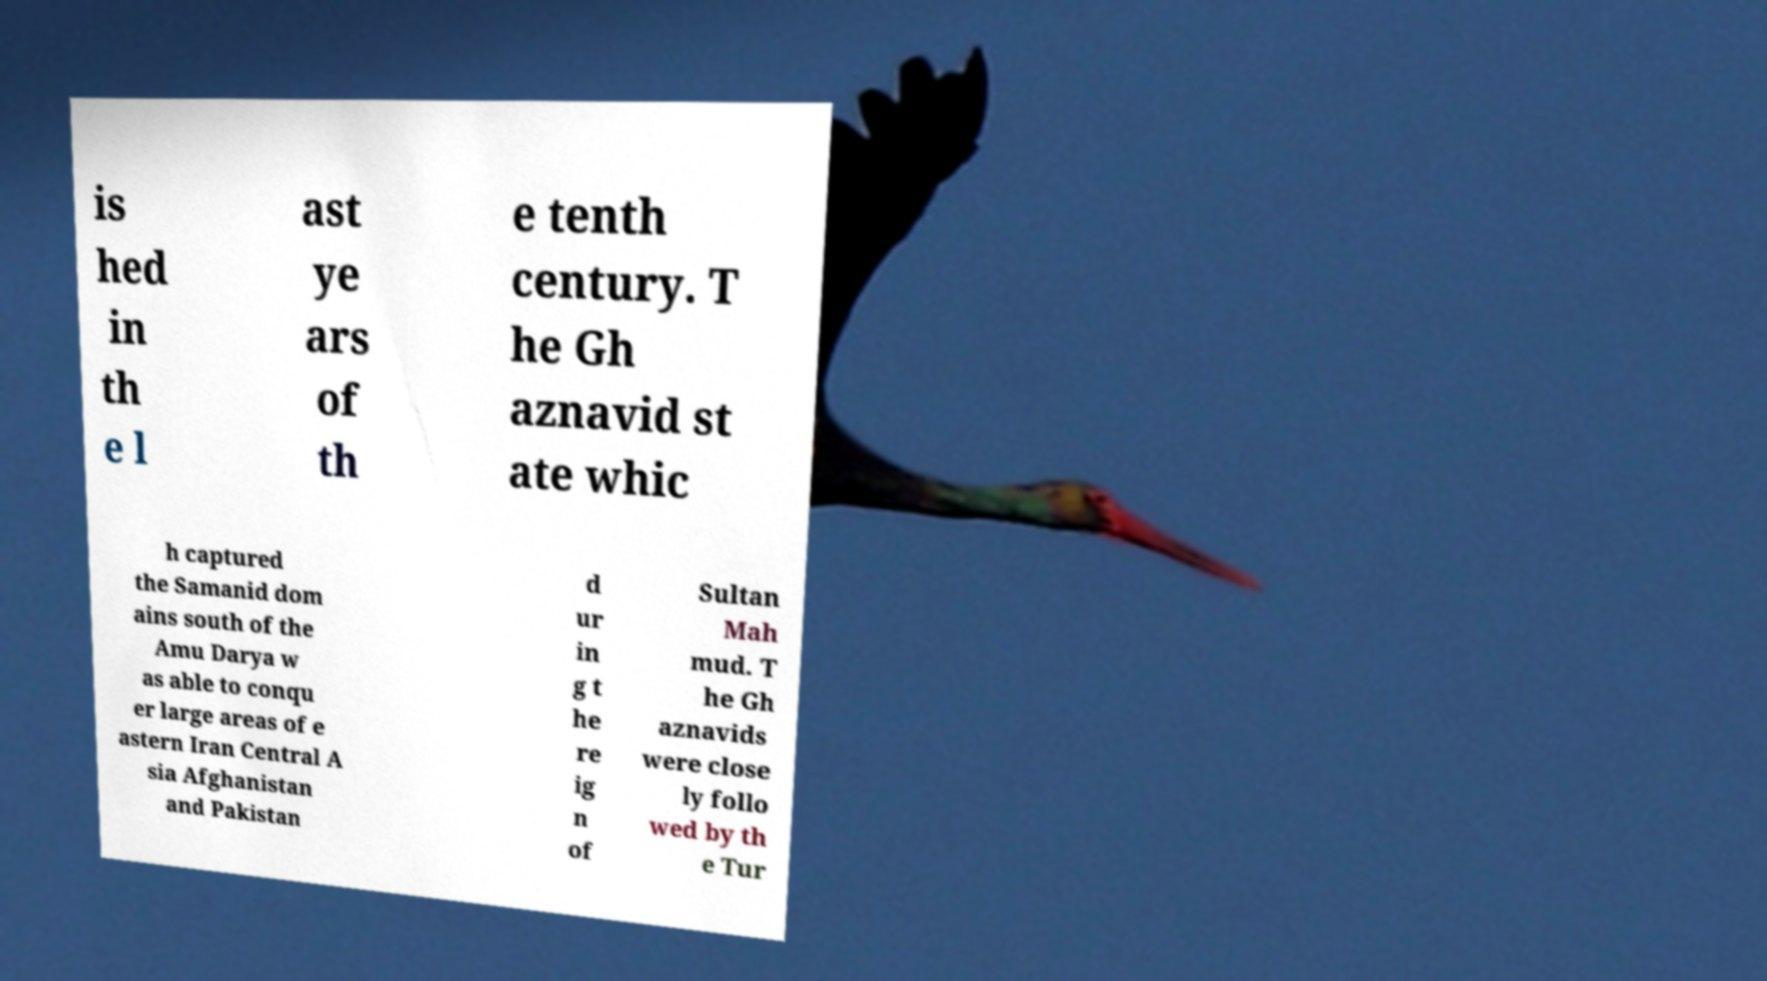Could you assist in decoding the text presented in this image and type it out clearly? is hed in th e l ast ye ars of th e tenth century. T he Gh aznavid st ate whic h captured the Samanid dom ains south of the Amu Darya w as able to conqu er large areas of e astern Iran Central A sia Afghanistan and Pakistan d ur in g t he re ig n of Sultan Mah mud. T he Gh aznavids were close ly follo wed by th e Tur 